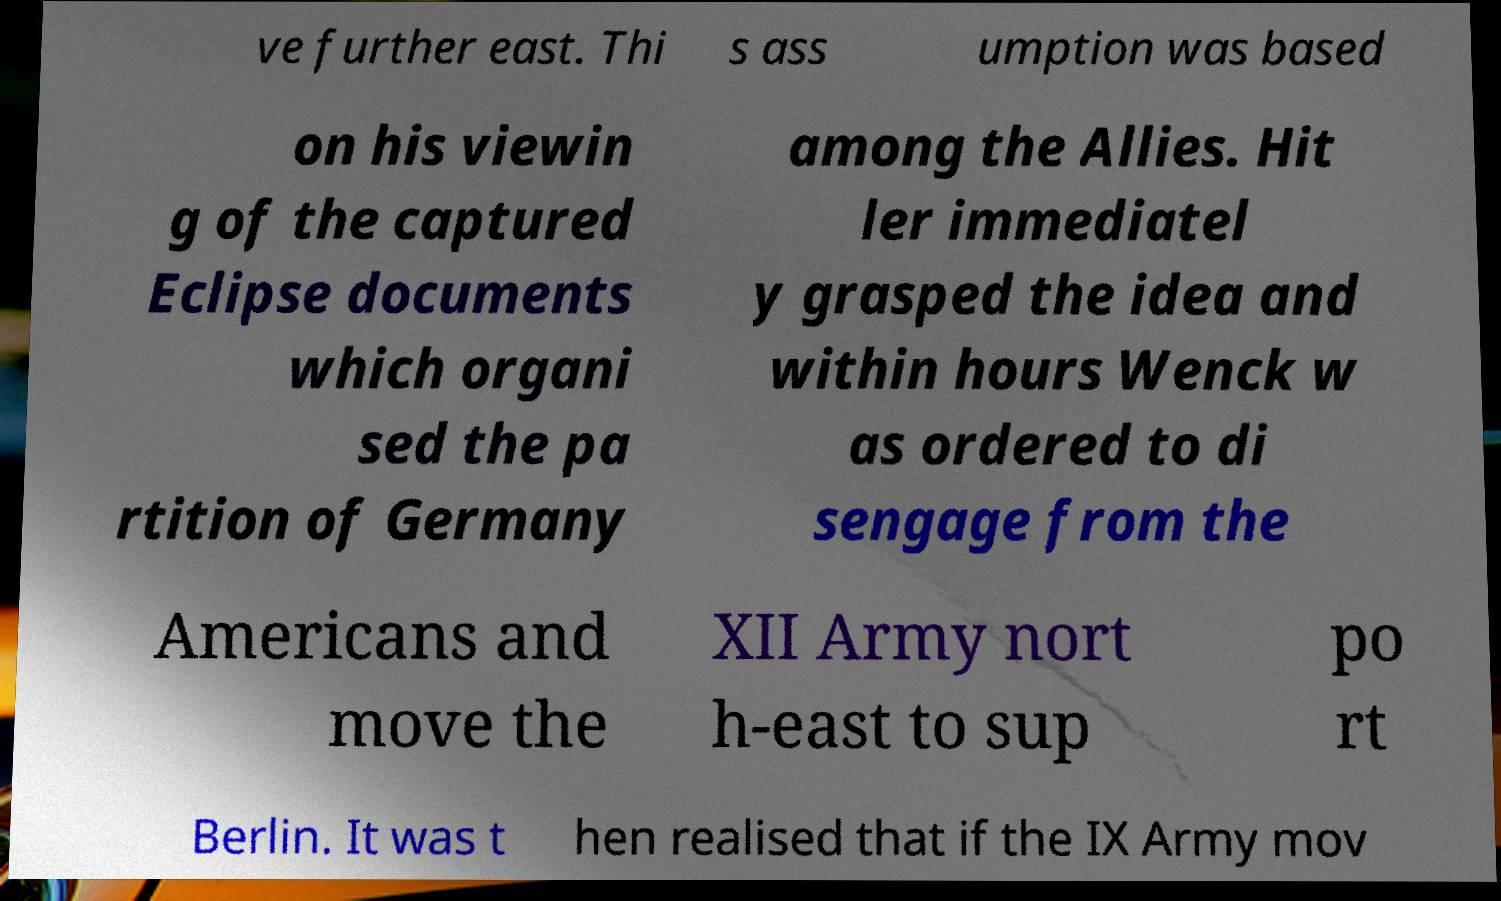I need the written content from this picture converted into text. Can you do that? ve further east. Thi s ass umption was based on his viewin g of the captured Eclipse documents which organi sed the pa rtition of Germany among the Allies. Hit ler immediatel y grasped the idea and within hours Wenck w as ordered to di sengage from the Americans and move the XII Army nort h-east to sup po rt Berlin. It was t hen realised that if the IX Army mov 